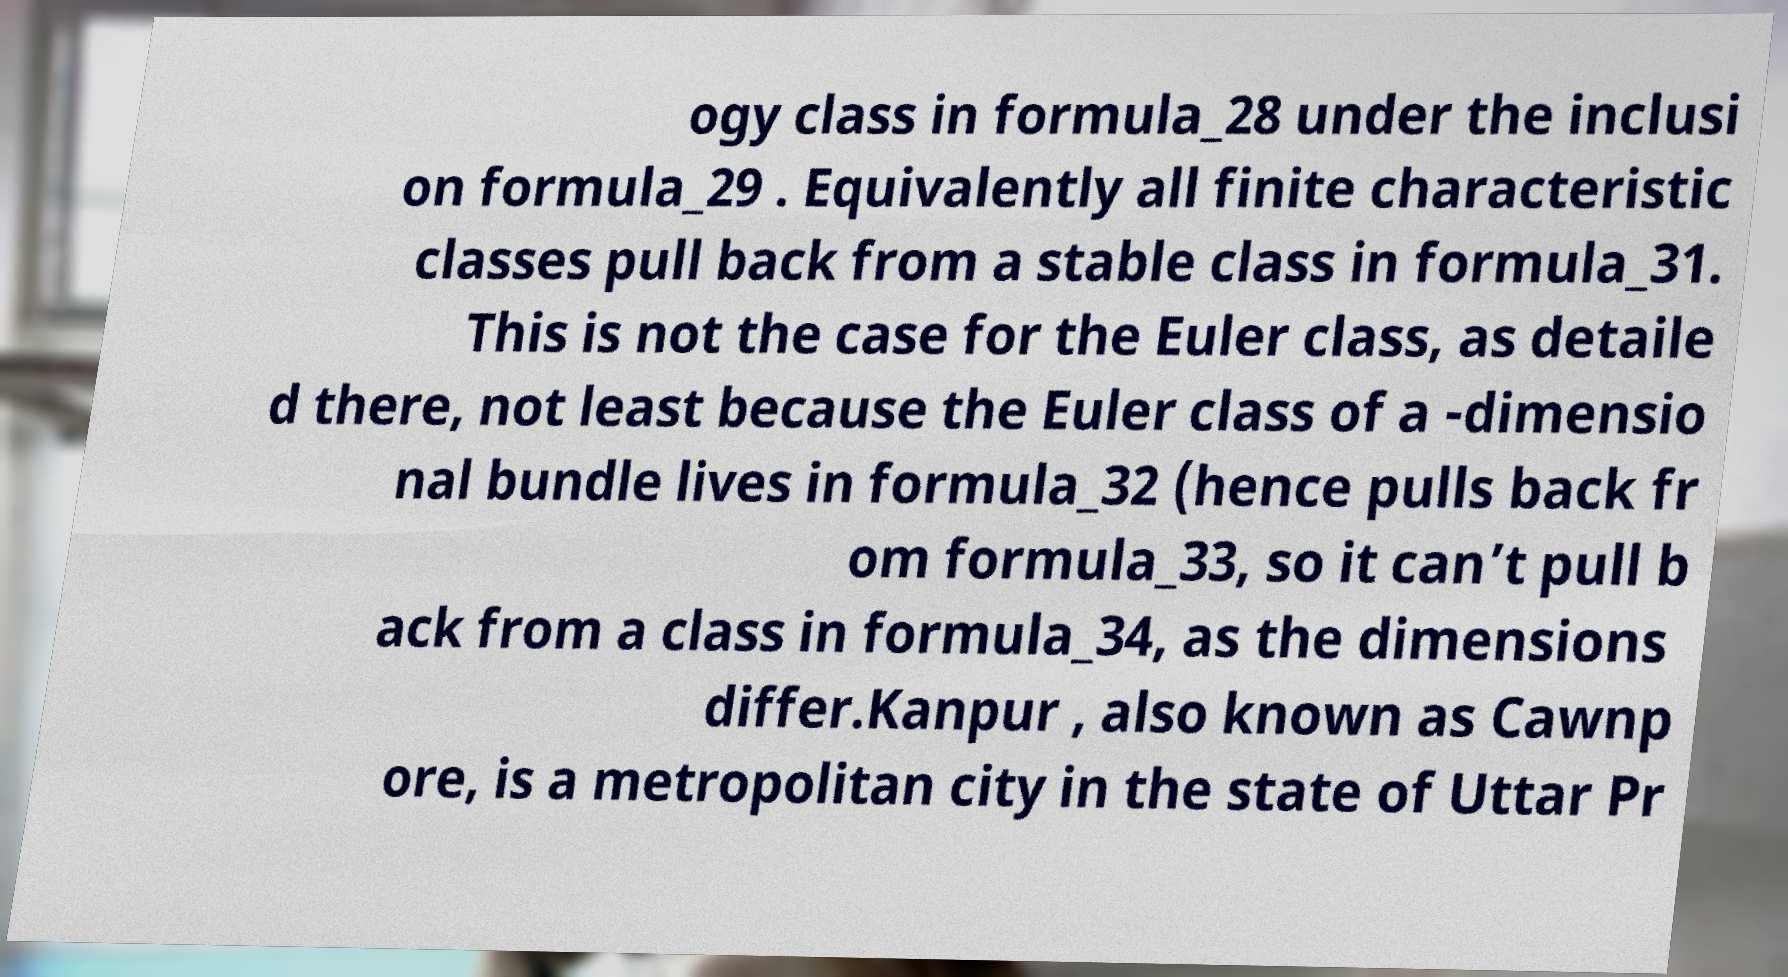Please read and relay the text visible in this image. What does it say? ogy class in formula_28 under the inclusi on formula_29 . Equivalently all finite characteristic classes pull back from a stable class in formula_31. This is not the case for the Euler class, as detaile d there, not least because the Euler class of a -dimensio nal bundle lives in formula_32 (hence pulls back fr om formula_33, so it can’t pull b ack from a class in formula_34, as the dimensions differ.Kanpur , also known as Cawnp ore, is a metropolitan city in the state of Uttar Pr 